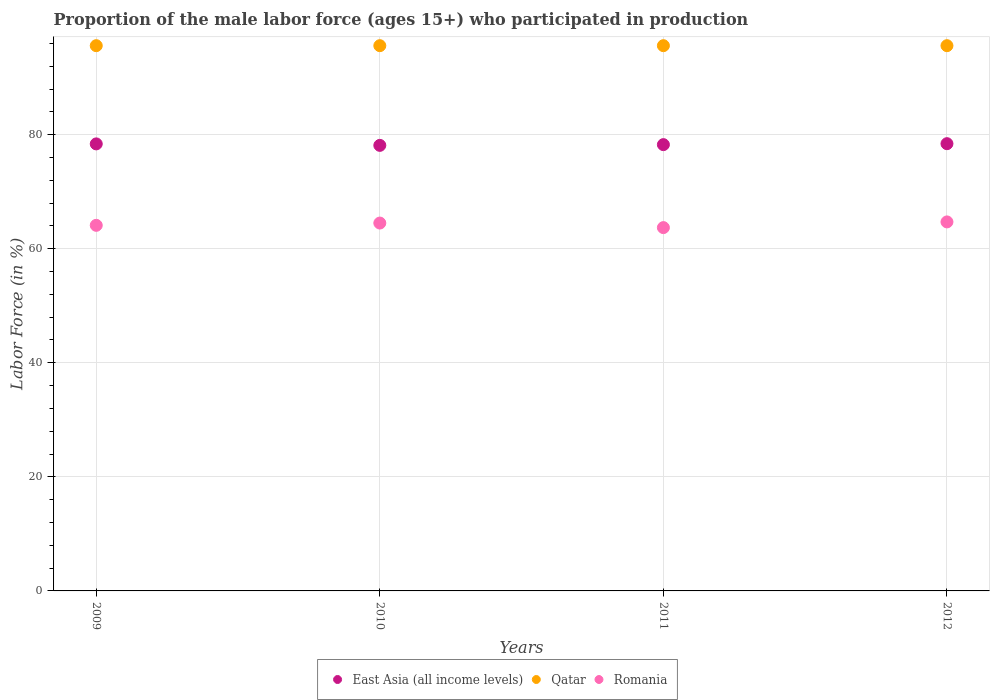What is the proportion of the male labor force who participated in production in Qatar in 2009?
Provide a short and direct response. 95.6. Across all years, what is the maximum proportion of the male labor force who participated in production in Romania?
Offer a terse response. 64.7. Across all years, what is the minimum proportion of the male labor force who participated in production in Qatar?
Your answer should be compact. 95.6. In which year was the proportion of the male labor force who participated in production in Romania maximum?
Your answer should be very brief. 2012. In which year was the proportion of the male labor force who participated in production in Romania minimum?
Your answer should be very brief. 2011. What is the total proportion of the male labor force who participated in production in East Asia (all income levels) in the graph?
Keep it short and to the point. 313.16. What is the difference between the proportion of the male labor force who participated in production in Qatar in 2009 and that in 2011?
Offer a very short reply. 0. What is the difference between the proportion of the male labor force who participated in production in East Asia (all income levels) in 2011 and the proportion of the male labor force who participated in production in Romania in 2012?
Your response must be concise. 13.55. What is the average proportion of the male labor force who participated in production in East Asia (all income levels) per year?
Give a very brief answer. 78.29. In the year 2010, what is the difference between the proportion of the male labor force who participated in production in East Asia (all income levels) and proportion of the male labor force who participated in production in Romania?
Ensure brevity in your answer.  13.62. In how many years, is the proportion of the male labor force who participated in production in Qatar greater than 84 %?
Provide a short and direct response. 4. What is the ratio of the proportion of the male labor force who participated in production in Qatar in 2009 to that in 2010?
Keep it short and to the point. 1. Is the proportion of the male labor force who participated in production in Romania in 2011 less than that in 2012?
Offer a terse response. Yes. Is the difference between the proportion of the male labor force who participated in production in East Asia (all income levels) in 2009 and 2010 greater than the difference between the proportion of the male labor force who participated in production in Romania in 2009 and 2010?
Give a very brief answer. Yes. What is the difference between the highest and the second highest proportion of the male labor force who participated in production in Romania?
Make the answer very short. 0.2. What is the difference between the highest and the lowest proportion of the male labor force who participated in production in East Asia (all income levels)?
Provide a short and direct response. 0.3. Does the proportion of the male labor force who participated in production in Qatar monotonically increase over the years?
Provide a short and direct response. No. Is the proportion of the male labor force who participated in production in East Asia (all income levels) strictly greater than the proportion of the male labor force who participated in production in Qatar over the years?
Ensure brevity in your answer.  No. Is the proportion of the male labor force who participated in production in Romania strictly less than the proportion of the male labor force who participated in production in Qatar over the years?
Offer a terse response. Yes. How many dotlines are there?
Make the answer very short. 3. How many years are there in the graph?
Offer a terse response. 4. Does the graph contain grids?
Provide a succinct answer. Yes. What is the title of the graph?
Your response must be concise. Proportion of the male labor force (ages 15+) who participated in production. What is the label or title of the X-axis?
Offer a terse response. Years. What is the label or title of the Y-axis?
Your answer should be compact. Labor Force (in %). What is the Labor Force (in %) in East Asia (all income levels) in 2009?
Offer a terse response. 78.38. What is the Labor Force (in %) in Qatar in 2009?
Provide a short and direct response. 95.6. What is the Labor Force (in %) of Romania in 2009?
Ensure brevity in your answer.  64.1. What is the Labor Force (in %) in East Asia (all income levels) in 2010?
Ensure brevity in your answer.  78.12. What is the Labor Force (in %) in Qatar in 2010?
Give a very brief answer. 95.6. What is the Labor Force (in %) of Romania in 2010?
Your answer should be compact. 64.5. What is the Labor Force (in %) in East Asia (all income levels) in 2011?
Provide a short and direct response. 78.25. What is the Labor Force (in %) of Qatar in 2011?
Give a very brief answer. 95.6. What is the Labor Force (in %) of Romania in 2011?
Offer a terse response. 63.7. What is the Labor Force (in %) of East Asia (all income levels) in 2012?
Make the answer very short. 78.42. What is the Labor Force (in %) of Qatar in 2012?
Give a very brief answer. 95.6. What is the Labor Force (in %) in Romania in 2012?
Your answer should be compact. 64.7. Across all years, what is the maximum Labor Force (in %) of East Asia (all income levels)?
Your answer should be compact. 78.42. Across all years, what is the maximum Labor Force (in %) of Qatar?
Ensure brevity in your answer.  95.6. Across all years, what is the maximum Labor Force (in %) in Romania?
Provide a short and direct response. 64.7. Across all years, what is the minimum Labor Force (in %) of East Asia (all income levels)?
Provide a succinct answer. 78.12. Across all years, what is the minimum Labor Force (in %) in Qatar?
Keep it short and to the point. 95.6. Across all years, what is the minimum Labor Force (in %) in Romania?
Offer a very short reply. 63.7. What is the total Labor Force (in %) of East Asia (all income levels) in the graph?
Your answer should be very brief. 313.16. What is the total Labor Force (in %) in Qatar in the graph?
Ensure brevity in your answer.  382.4. What is the total Labor Force (in %) in Romania in the graph?
Make the answer very short. 257. What is the difference between the Labor Force (in %) of East Asia (all income levels) in 2009 and that in 2010?
Your response must be concise. 0.26. What is the difference between the Labor Force (in %) in Qatar in 2009 and that in 2010?
Ensure brevity in your answer.  0. What is the difference between the Labor Force (in %) of East Asia (all income levels) in 2009 and that in 2011?
Ensure brevity in your answer.  0.13. What is the difference between the Labor Force (in %) of Romania in 2009 and that in 2011?
Provide a succinct answer. 0.4. What is the difference between the Labor Force (in %) in East Asia (all income levels) in 2009 and that in 2012?
Your answer should be very brief. -0.04. What is the difference between the Labor Force (in %) in Qatar in 2009 and that in 2012?
Provide a succinct answer. 0. What is the difference between the Labor Force (in %) of Romania in 2009 and that in 2012?
Provide a succinct answer. -0.6. What is the difference between the Labor Force (in %) of East Asia (all income levels) in 2010 and that in 2011?
Offer a very short reply. -0.13. What is the difference between the Labor Force (in %) in Qatar in 2010 and that in 2011?
Your answer should be compact. 0. What is the difference between the Labor Force (in %) of East Asia (all income levels) in 2010 and that in 2012?
Keep it short and to the point. -0.3. What is the difference between the Labor Force (in %) in Qatar in 2010 and that in 2012?
Provide a succinct answer. 0. What is the difference between the Labor Force (in %) of East Asia (all income levels) in 2011 and that in 2012?
Give a very brief answer. -0.17. What is the difference between the Labor Force (in %) in Qatar in 2011 and that in 2012?
Make the answer very short. 0. What is the difference between the Labor Force (in %) in Romania in 2011 and that in 2012?
Provide a short and direct response. -1. What is the difference between the Labor Force (in %) of East Asia (all income levels) in 2009 and the Labor Force (in %) of Qatar in 2010?
Provide a succinct answer. -17.22. What is the difference between the Labor Force (in %) in East Asia (all income levels) in 2009 and the Labor Force (in %) in Romania in 2010?
Keep it short and to the point. 13.88. What is the difference between the Labor Force (in %) of Qatar in 2009 and the Labor Force (in %) of Romania in 2010?
Provide a short and direct response. 31.1. What is the difference between the Labor Force (in %) of East Asia (all income levels) in 2009 and the Labor Force (in %) of Qatar in 2011?
Keep it short and to the point. -17.22. What is the difference between the Labor Force (in %) in East Asia (all income levels) in 2009 and the Labor Force (in %) in Romania in 2011?
Offer a terse response. 14.68. What is the difference between the Labor Force (in %) of Qatar in 2009 and the Labor Force (in %) of Romania in 2011?
Keep it short and to the point. 31.9. What is the difference between the Labor Force (in %) in East Asia (all income levels) in 2009 and the Labor Force (in %) in Qatar in 2012?
Your answer should be very brief. -17.22. What is the difference between the Labor Force (in %) of East Asia (all income levels) in 2009 and the Labor Force (in %) of Romania in 2012?
Your answer should be very brief. 13.68. What is the difference between the Labor Force (in %) in Qatar in 2009 and the Labor Force (in %) in Romania in 2012?
Provide a short and direct response. 30.9. What is the difference between the Labor Force (in %) in East Asia (all income levels) in 2010 and the Labor Force (in %) in Qatar in 2011?
Ensure brevity in your answer.  -17.48. What is the difference between the Labor Force (in %) of East Asia (all income levels) in 2010 and the Labor Force (in %) of Romania in 2011?
Offer a terse response. 14.42. What is the difference between the Labor Force (in %) in Qatar in 2010 and the Labor Force (in %) in Romania in 2011?
Your answer should be compact. 31.9. What is the difference between the Labor Force (in %) of East Asia (all income levels) in 2010 and the Labor Force (in %) of Qatar in 2012?
Give a very brief answer. -17.48. What is the difference between the Labor Force (in %) of East Asia (all income levels) in 2010 and the Labor Force (in %) of Romania in 2012?
Offer a terse response. 13.42. What is the difference between the Labor Force (in %) of Qatar in 2010 and the Labor Force (in %) of Romania in 2012?
Your response must be concise. 30.9. What is the difference between the Labor Force (in %) in East Asia (all income levels) in 2011 and the Labor Force (in %) in Qatar in 2012?
Provide a short and direct response. -17.35. What is the difference between the Labor Force (in %) in East Asia (all income levels) in 2011 and the Labor Force (in %) in Romania in 2012?
Provide a short and direct response. 13.55. What is the difference between the Labor Force (in %) in Qatar in 2011 and the Labor Force (in %) in Romania in 2012?
Your answer should be compact. 30.9. What is the average Labor Force (in %) in East Asia (all income levels) per year?
Ensure brevity in your answer.  78.29. What is the average Labor Force (in %) of Qatar per year?
Your answer should be compact. 95.6. What is the average Labor Force (in %) in Romania per year?
Offer a terse response. 64.25. In the year 2009, what is the difference between the Labor Force (in %) of East Asia (all income levels) and Labor Force (in %) of Qatar?
Your answer should be very brief. -17.22. In the year 2009, what is the difference between the Labor Force (in %) in East Asia (all income levels) and Labor Force (in %) in Romania?
Make the answer very short. 14.28. In the year 2009, what is the difference between the Labor Force (in %) in Qatar and Labor Force (in %) in Romania?
Offer a very short reply. 31.5. In the year 2010, what is the difference between the Labor Force (in %) of East Asia (all income levels) and Labor Force (in %) of Qatar?
Ensure brevity in your answer.  -17.48. In the year 2010, what is the difference between the Labor Force (in %) in East Asia (all income levels) and Labor Force (in %) in Romania?
Your response must be concise. 13.62. In the year 2010, what is the difference between the Labor Force (in %) of Qatar and Labor Force (in %) of Romania?
Keep it short and to the point. 31.1. In the year 2011, what is the difference between the Labor Force (in %) of East Asia (all income levels) and Labor Force (in %) of Qatar?
Provide a succinct answer. -17.35. In the year 2011, what is the difference between the Labor Force (in %) of East Asia (all income levels) and Labor Force (in %) of Romania?
Offer a terse response. 14.55. In the year 2011, what is the difference between the Labor Force (in %) of Qatar and Labor Force (in %) of Romania?
Make the answer very short. 31.9. In the year 2012, what is the difference between the Labor Force (in %) of East Asia (all income levels) and Labor Force (in %) of Qatar?
Provide a succinct answer. -17.18. In the year 2012, what is the difference between the Labor Force (in %) in East Asia (all income levels) and Labor Force (in %) in Romania?
Your response must be concise. 13.72. In the year 2012, what is the difference between the Labor Force (in %) in Qatar and Labor Force (in %) in Romania?
Make the answer very short. 30.9. What is the ratio of the Labor Force (in %) of Romania in 2009 to that in 2010?
Your response must be concise. 0.99. What is the ratio of the Labor Force (in %) of East Asia (all income levels) in 2009 to that in 2011?
Your answer should be very brief. 1. What is the ratio of the Labor Force (in %) in Qatar in 2009 to that in 2011?
Offer a terse response. 1. What is the ratio of the Labor Force (in %) of East Asia (all income levels) in 2009 to that in 2012?
Provide a short and direct response. 1. What is the ratio of the Labor Force (in %) of Romania in 2009 to that in 2012?
Keep it short and to the point. 0.99. What is the ratio of the Labor Force (in %) of Qatar in 2010 to that in 2011?
Offer a terse response. 1. What is the ratio of the Labor Force (in %) in Romania in 2010 to that in 2011?
Offer a terse response. 1.01. What is the ratio of the Labor Force (in %) of East Asia (all income levels) in 2010 to that in 2012?
Ensure brevity in your answer.  1. What is the ratio of the Labor Force (in %) of Qatar in 2010 to that in 2012?
Give a very brief answer. 1. What is the ratio of the Labor Force (in %) in Romania in 2010 to that in 2012?
Ensure brevity in your answer.  1. What is the ratio of the Labor Force (in %) of East Asia (all income levels) in 2011 to that in 2012?
Your answer should be compact. 1. What is the ratio of the Labor Force (in %) of Romania in 2011 to that in 2012?
Give a very brief answer. 0.98. What is the difference between the highest and the second highest Labor Force (in %) in East Asia (all income levels)?
Your answer should be compact. 0.04. What is the difference between the highest and the lowest Labor Force (in %) of East Asia (all income levels)?
Give a very brief answer. 0.3. What is the difference between the highest and the lowest Labor Force (in %) in Qatar?
Ensure brevity in your answer.  0. What is the difference between the highest and the lowest Labor Force (in %) of Romania?
Provide a succinct answer. 1. 